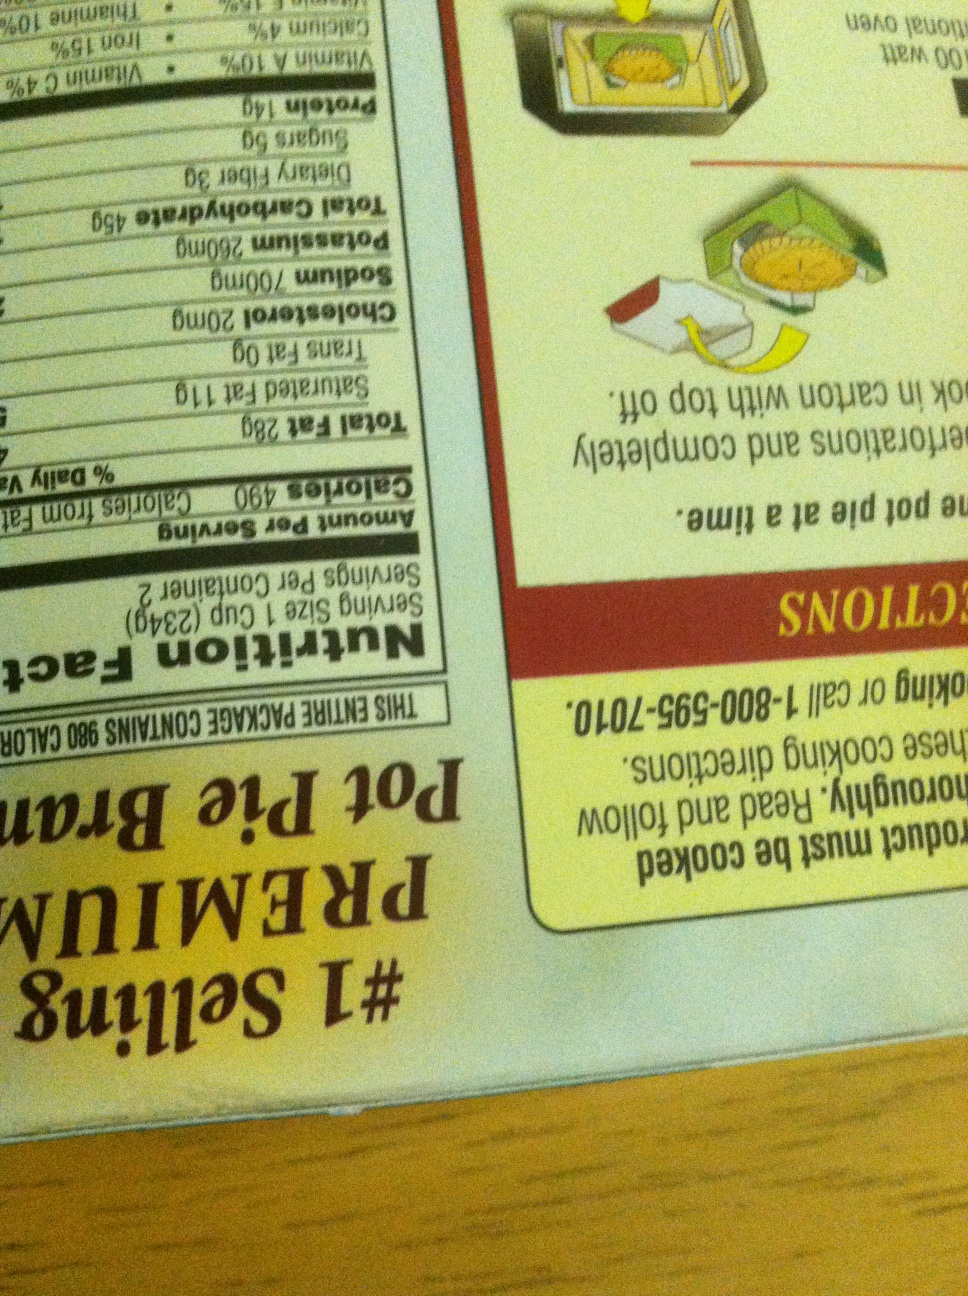Could you please tell me the sodium content of the pot pie in this box? Thank you. The sodium content of the pot pie in this box is 700 mg. Please make sure to consider this amount in the context of your daily dietary requirements. 